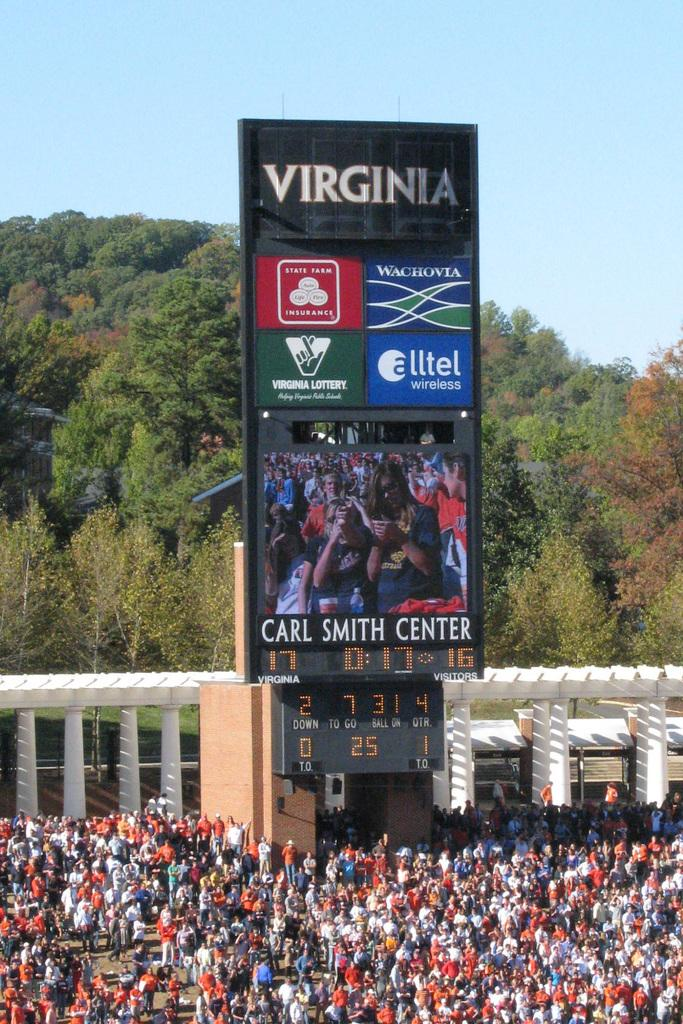<image>
Write a terse but informative summary of the picture. A large crowd at the Carl Smith Center. 